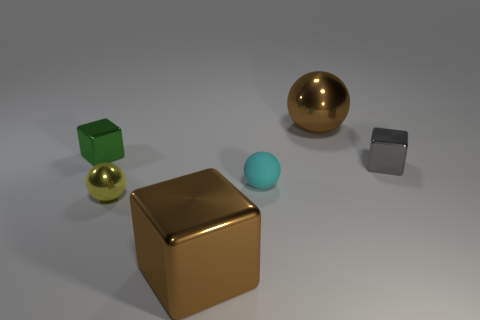Add 2 big red rubber spheres. How many objects exist? 8 Subtract all large shiny cubes. How many cubes are left? 2 Subtract all large rubber blocks. Subtract all brown shiny balls. How many objects are left? 5 Add 2 rubber objects. How many rubber objects are left? 3 Add 6 large cyan matte spheres. How many large cyan matte spheres exist? 6 Subtract all yellow spheres. How many spheres are left? 2 Subtract 0 yellow cylinders. How many objects are left? 6 Subtract 2 balls. How many balls are left? 1 Subtract all yellow balls. Subtract all cyan cubes. How many balls are left? 2 Subtract all green blocks. How many gray balls are left? 0 